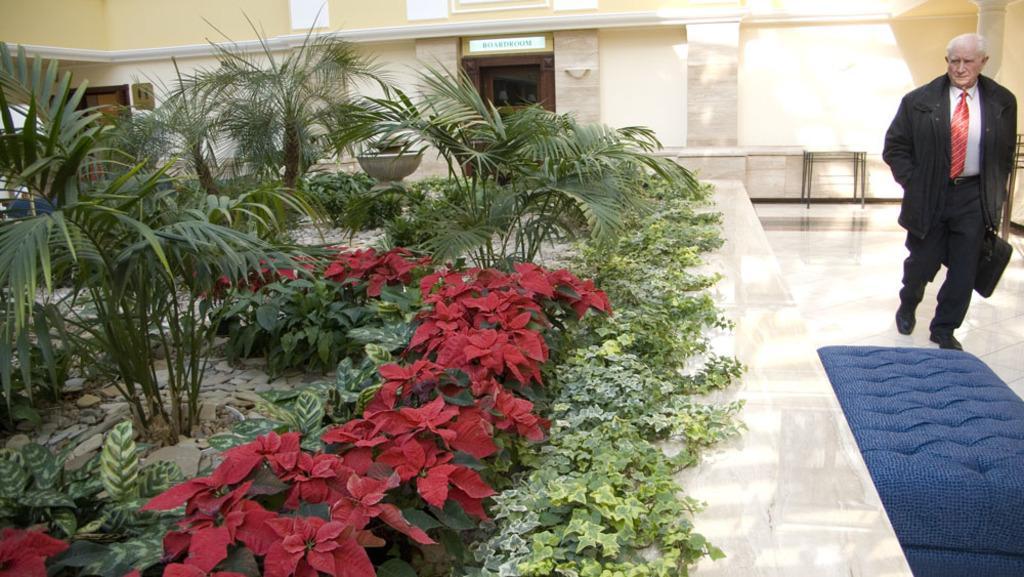Please provide a concise description of this image. On the right of the image there is a person walking on the floor. On the left side of the image there are few flower plants. In the background there is a building. 